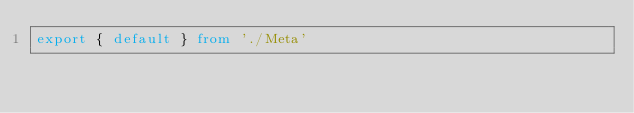Convert code to text. <code><loc_0><loc_0><loc_500><loc_500><_TypeScript_>export { default } from './Meta'</code> 